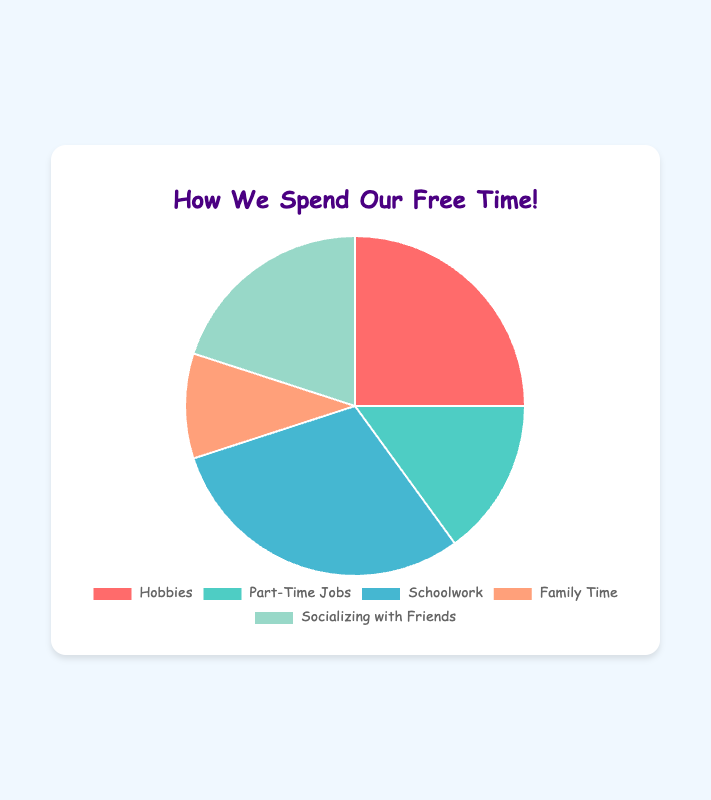What activity occupies the largest percentage of free time among teenagers? The activity with the largest percentage is the one with the highest value on the pie chart. Here, it is Schoolwork at 30%.
Answer: Schoolwork Which activity takes up less time, Hobbies or Socializing with Friends? We compare the percentages of Hobbies (25%) and Socializing with Friends (20%). Since 20% is less than 25%, Socializing with Friends takes up less time.
Answer: Socializing with Friends What is the total percentage combined for Family Time and Part-Time Jobs? To find the total, we add the percentages of Family Time (10%) and Part-Time Jobs (15%). 10% + 15% = 25%.
Answer: 25% How much more time is spent on Schoolwork compared to Family Time? To find this, we subtract the percentage of Family Time (10%) from the percentage of Schoolwork (30%). 30% - 10% = 20%.
Answer: 20% Which two activities together make up half of the teenagers' free time? We are looking for two activities whose combined percentages equal 50%. Hobbies (25%) and Socializing with Friends (20%) together make 45%. Hobbies (25%) and Part-Time Jobs (15%) together make 40%. The correct combination is Schoolwork (30%) and Socializing with Friends (20%). 30% + 20% = 50%.
Answer: Schoolwork and Socializing with Friends By how much does the percentage of Hobbies exceed Family Time? Subtract the percentage of Family Time (10%) from the percentage of Hobbies (25%). 25% - 10% = 15%.
Answer: 15% If you group Part-Time Jobs and Family Time together, do they represent more or less percentage than Hobbies? The combined percentage for Part-Time Jobs (15%) and Family Time (10%) is 25%. This is equal to the percentage for Hobbies (25%).
Answer: Equal Which activity is represented by the green slice of the pie chart? We look at the colored slices to identify the green one. The green slice corresponds to Socializing with Friends.
Answer: Socializing with Friends 